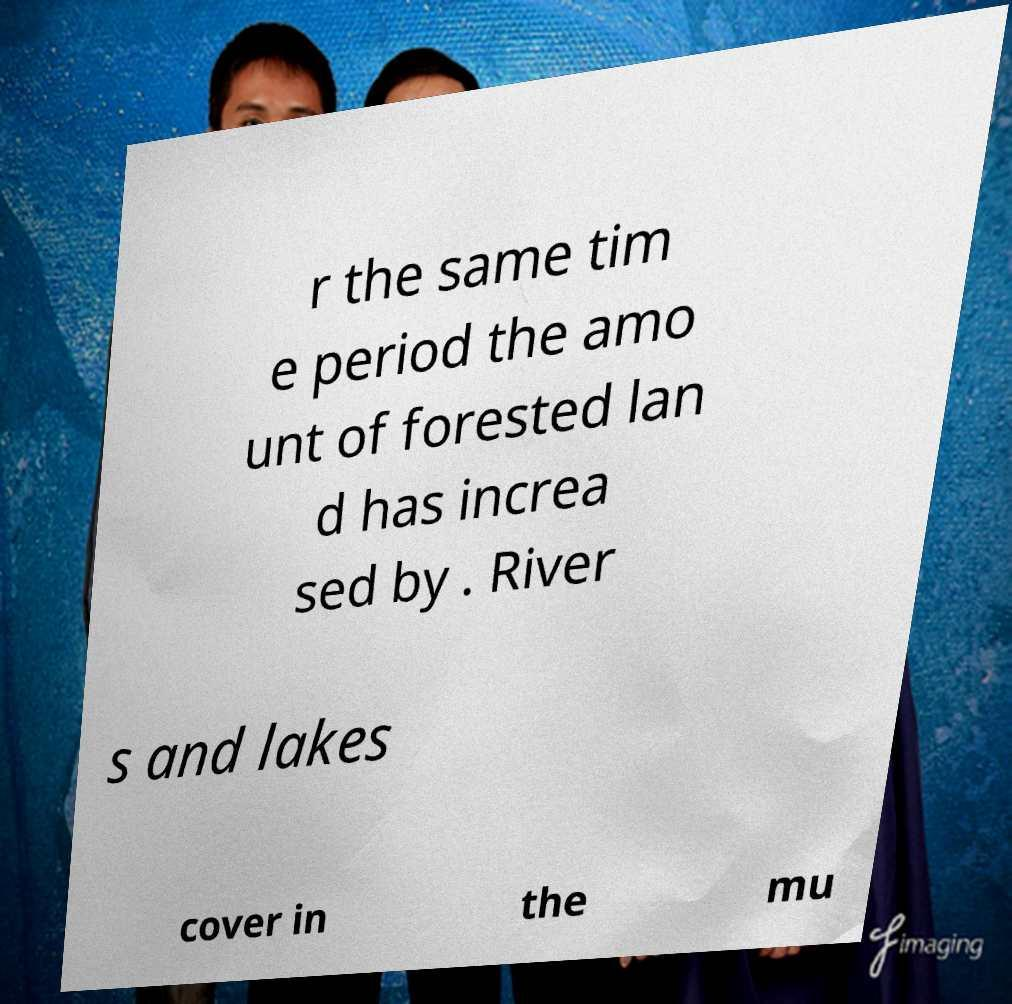There's text embedded in this image that I need extracted. Can you transcribe it verbatim? r the same tim e period the amo unt of forested lan d has increa sed by . River s and lakes cover in the mu 